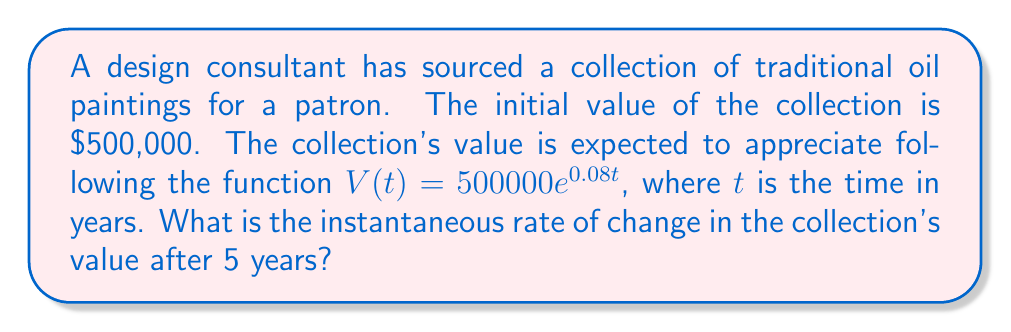Give your solution to this math problem. To find the instantaneous rate of change in the collection's value after 5 years, we need to find the derivative of the given function and evaluate it at $t = 5$.

Step 1: Identify the given function
$V(t) = 500000e^{0.08t}$

Step 2: Find the derivative of the function
Using the chain rule, we get:
$$\frac{dV}{dt} = 500000 \cdot 0.08 \cdot e^{0.08t}$$
$$\frac{dV}{dt} = 40000e^{0.08t}$$

Step 3: Evaluate the derivative at $t = 5$
$$\frac{dV}{dt}\bigg|_{t=5} = 40000e^{0.08(5)}$$
$$\frac{dV}{dt}\bigg|_{t=5} = 40000e^{0.4}$$
$$\frac{dV}{dt}\bigg|_{t=5} = 40000 \cdot 1.4918$$
$$\frac{dV}{dt}\bigg|_{t=5} = 59,672$$

Therefore, the instantaneous rate of change in the collection's value after 5 years is approximately $59,672 per year.
Answer: $59,672 per year 